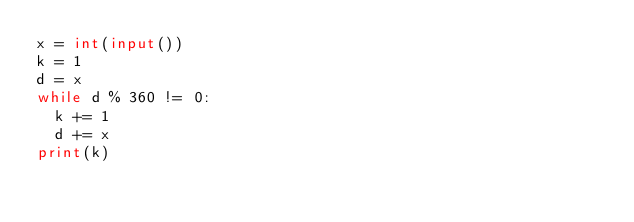<code> <loc_0><loc_0><loc_500><loc_500><_Python_>x = int(input())
k = 1
d = x
while d % 360 != 0:
  k += 1
  d += x
print(k)</code> 